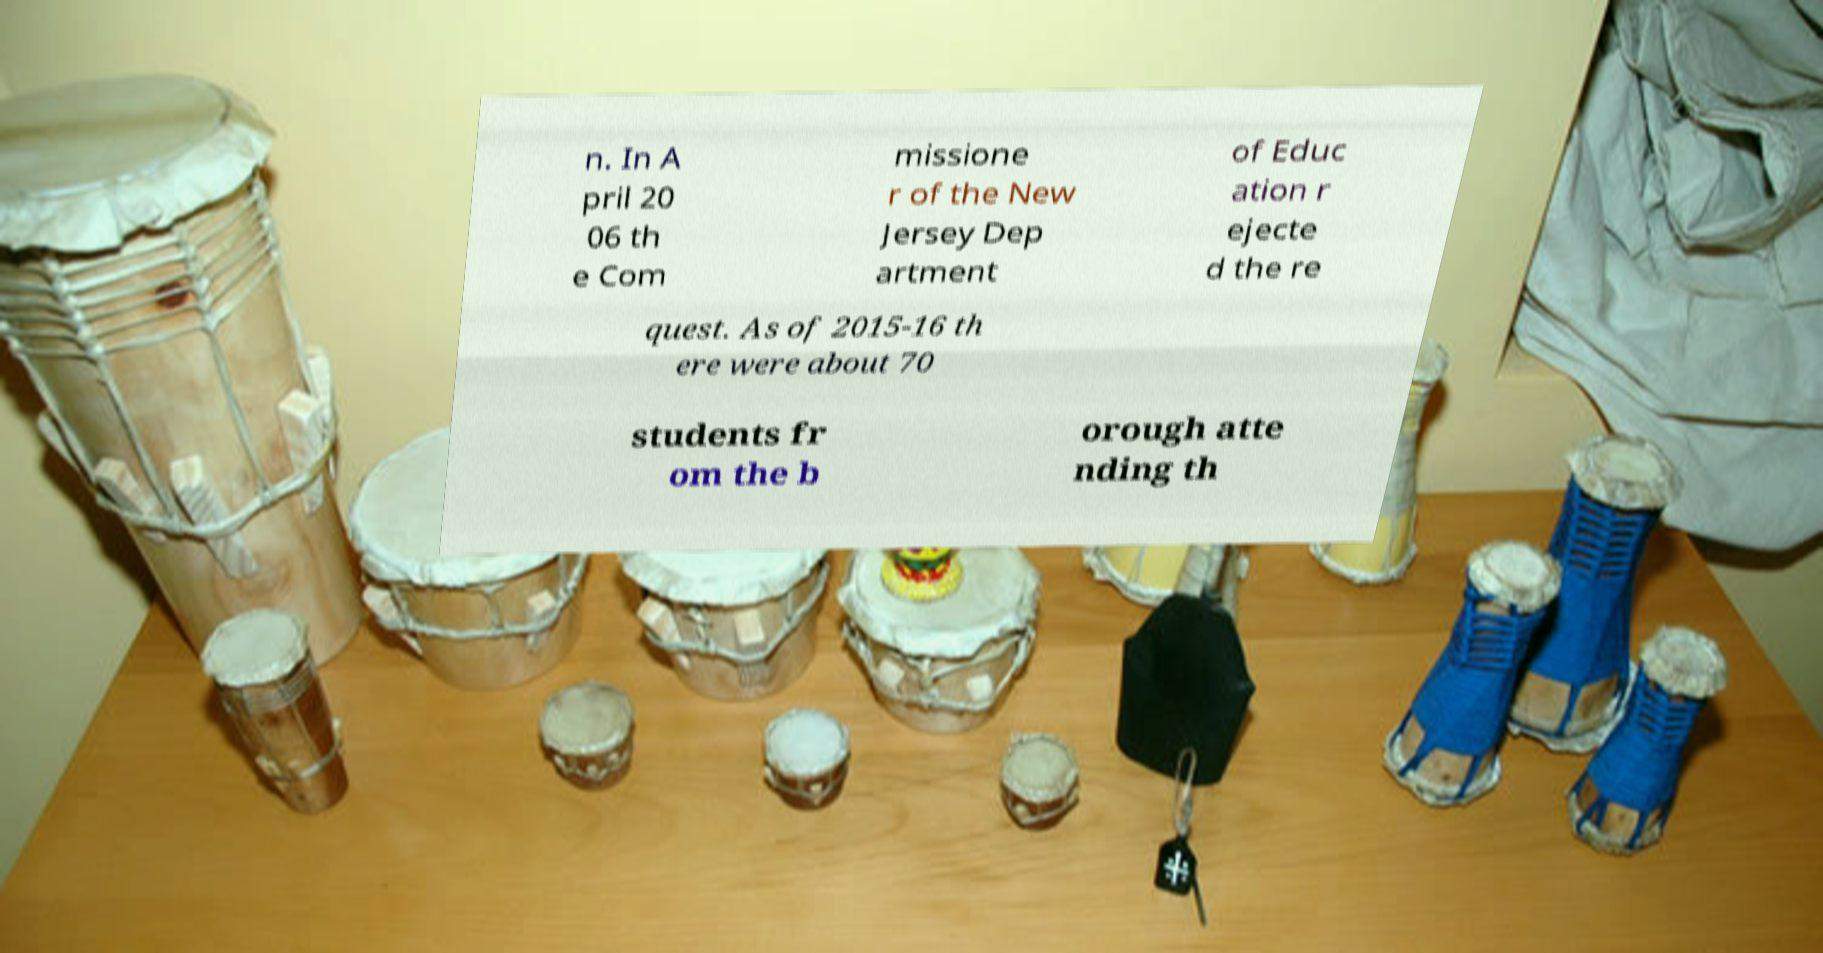Please read and relay the text visible in this image. What does it say? n. In A pril 20 06 th e Com missione r of the New Jersey Dep artment of Educ ation r ejecte d the re quest. As of 2015-16 th ere were about 70 students fr om the b orough atte nding th 